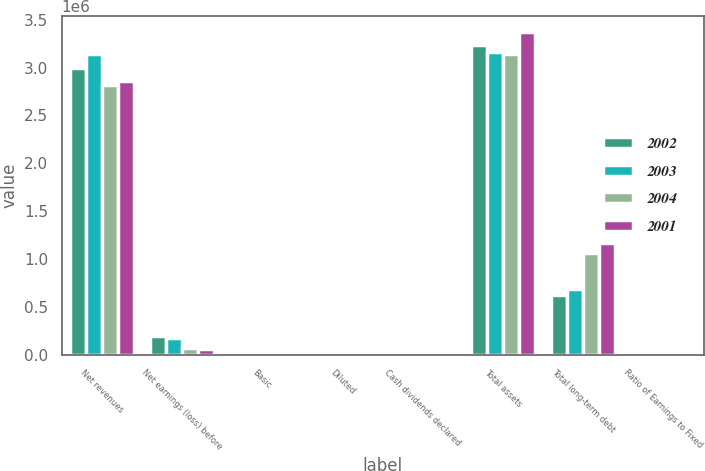<chart> <loc_0><loc_0><loc_500><loc_500><stacked_bar_chart><ecel><fcel>Net revenues<fcel>Net earnings (loss) before<fcel>Basic<fcel>Diluted<fcel>Cash dividends declared<fcel>Total assets<fcel>Total long-term debt<fcel>Ratio of Earnings to Fixed<nl><fcel>2002<fcel>2.99751e+06<fcel>195977<fcel>1.11<fcel>0.96<fcel>0.24<fcel>3.24066e+06<fcel>626822<fcel>6.93<nl><fcel>2003<fcel>3.13866e+06<fcel>175015<fcel>1.01<fcel>0.94<fcel>0.12<fcel>3.16338e+06<fcel>688204<fcel>4.56<nl><fcel>2004<fcel>2.81623e+06<fcel>75058<fcel>0.43<fcel>0.43<fcel>0.12<fcel>3.14288e+06<fcel>1.05912e+06<fcel>2.05<nl><fcel>2001<fcel>2.85634e+06<fcel>60798<fcel>0.35<fcel>0.33<fcel>0.12<fcel>3.36898e+06<fcel>1.16795e+06<fcel>1.76<nl></chart> 